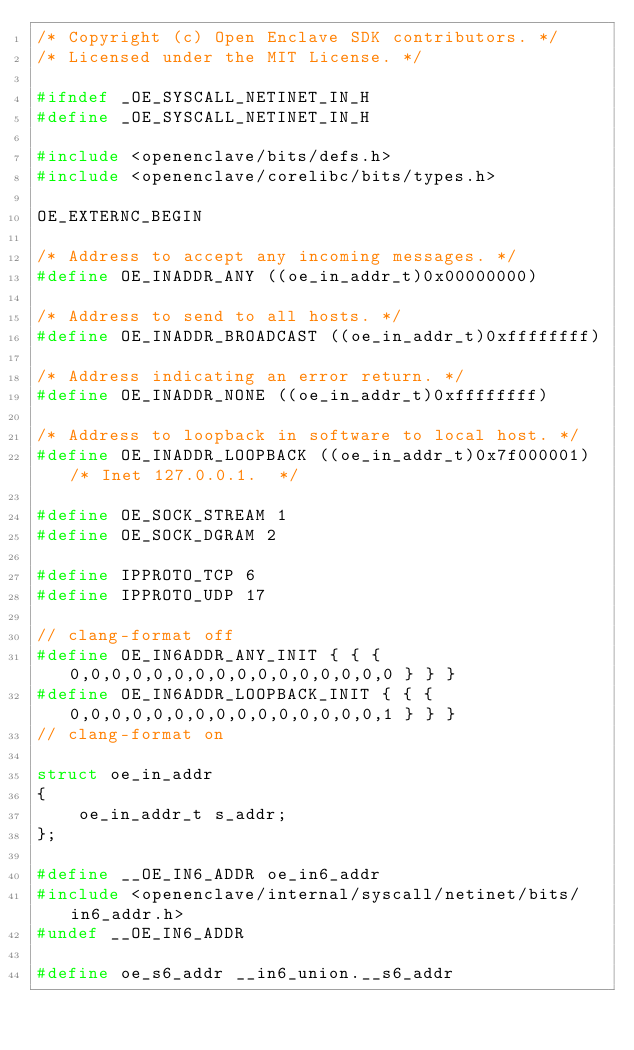Convert code to text. <code><loc_0><loc_0><loc_500><loc_500><_C_>/* Copyright (c) Open Enclave SDK contributors. */
/* Licensed under the MIT License. */

#ifndef _OE_SYSCALL_NETINET_IN_H
#define _OE_SYSCALL_NETINET_IN_H

#include <openenclave/bits/defs.h>
#include <openenclave/corelibc/bits/types.h>

OE_EXTERNC_BEGIN

/* Address to accept any incoming messages. */
#define OE_INADDR_ANY ((oe_in_addr_t)0x00000000)

/* Address to send to all hosts. */
#define OE_INADDR_BROADCAST ((oe_in_addr_t)0xffffffff)

/* Address indicating an error return. */
#define OE_INADDR_NONE ((oe_in_addr_t)0xffffffff)

/* Address to loopback in software to local host. */
#define OE_INADDR_LOOPBACK ((oe_in_addr_t)0x7f000001) /* Inet 127.0.0.1.  */

#define OE_SOCK_STREAM 1
#define OE_SOCK_DGRAM 2

#define IPPROTO_TCP 6
#define IPPROTO_UDP 17

// clang-format off
#define OE_IN6ADDR_ANY_INIT { { { 0,0,0,0,0,0,0,0,0,0,0,0,0,0,0,0 } } }
#define OE_IN6ADDR_LOOPBACK_INIT { { { 0,0,0,0,0,0,0,0,0,0,0,0,0,0,0,1 } } }
// clang-format on

struct oe_in_addr
{
    oe_in_addr_t s_addr;
};

#define __OE_IN6_ADDR oe_in6_addr
#include <openenclave/internal/syscall/netinet/bits/in6_addr.h>
#undef __OE_IN6_ADDR

#define oe_s6_addr __in6_union.__s6_addr</code> 